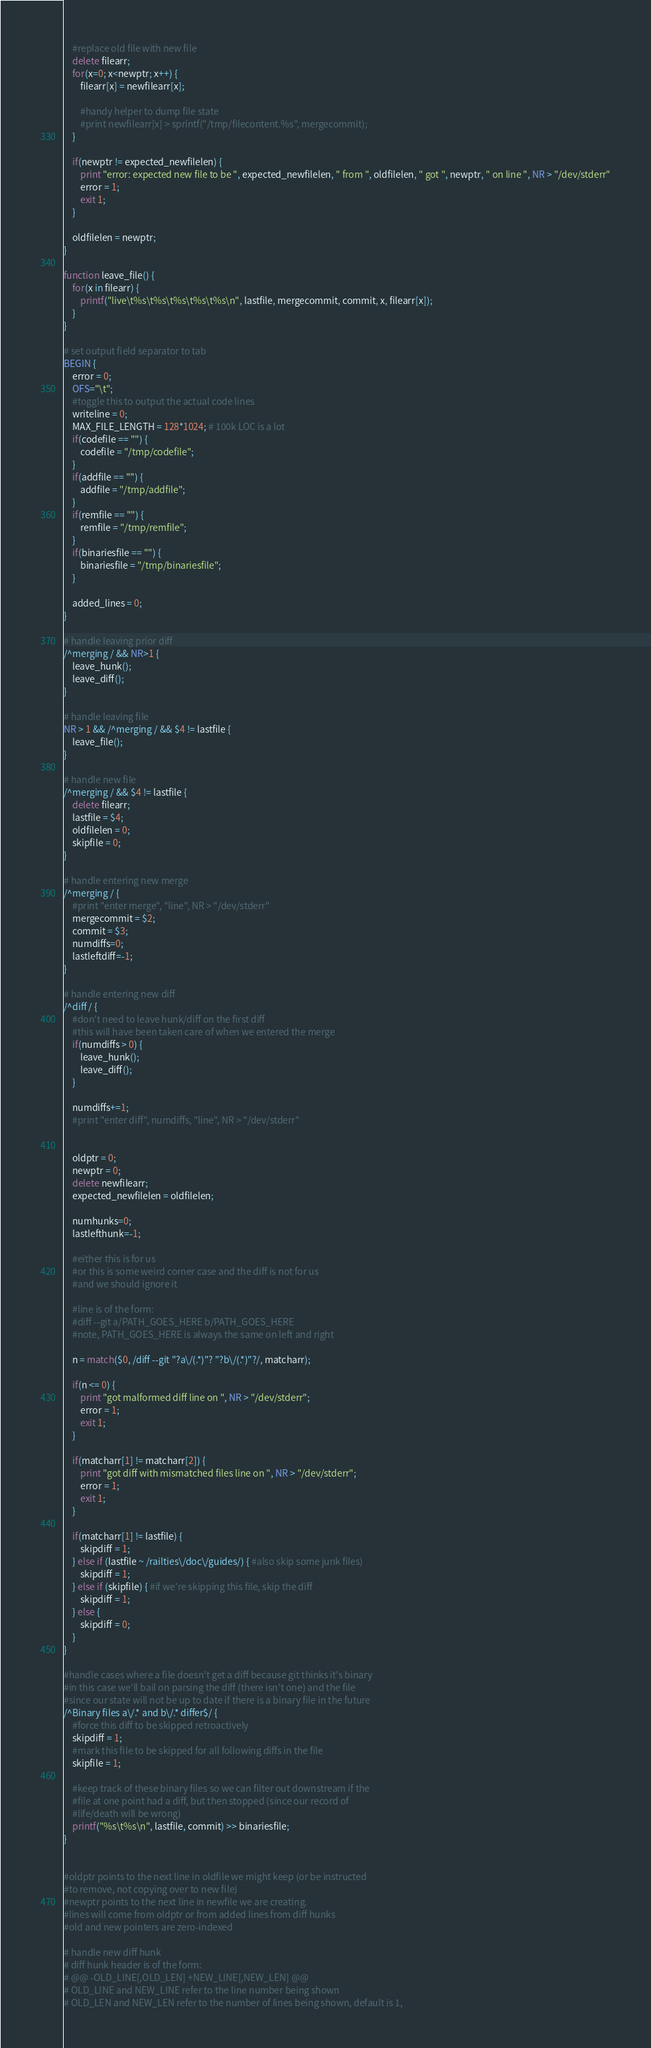Convert code to text. <code><loc_0><loc_0><loc_500><loc_500><_Awk_>
    #replace old file with new file
    delete filearr;
    for(x=0; x<newptr; x++) {
        filearr[x] = newfilearr[x];

        #handy helper to dump file state
        #print newfilearr[x] > sprintf("/tmp/filecontent.%s", mergecommit);
    }

    if(newptr != expected_newfilelen) {
        print "error: expected new file to be ", expected_newfilelen, " from ", oldfilelen, " got ", newptr, " on line ", NR > "/dev/stderr"
        error = 1;
        exit 1;
    }

    oldfilelen = newptr;
}

function leave_file() {
    for(x in filearr) {
        printf("live\t%s\t%s\t%s\t%s\t%s\n", lastfile, mergecommit, commit, x, filearr[x]);
    }
}

# set output field separator to tab
BEGIN {
    error = 0;
    OFS="\t";
    #toggle this to output the actual code lines
    writeline = 0;
    MAX_FILE_LENGTH = 128*1024; # 100k LOC is a lot
    if(codefile == "") {
        codefile = "/tmp/codefile";
    }
    if(addfile == "") {
        addfile = "/tmp/addfile";
    }
    if(remfile == "") {
        remfile = "/tmp/remfile";
    }
    if(binariesfile == "") {
        binariesfile = "/tmp/binariesfile";
    }

    added_lines = 0;
}

# handle leaving prior diff
/^merging / && NR>1 {
    leave_hunk();
    leave_diff();
}

# handle leaving file
NR > 1 && /^merging / && $4 != lastfile {
    leave_file();
}

# handle new file
/^merging / && $4 != lastfile {
    delete filearr;
    lastfile = $4;
    oldfilelen = 0;
    skipfile = 0;
}

# handle entering new merge
/^merging / {
    #print "enter merge", "line", NR > "/dev/stderr"
    mergecommit = $2;
    commit = $3;
    numdiffs=0;
    lastleftdiff=-1;
}

# handle entering new diff
/^diff / {
    #don't need to leave hunk/diff on the first diff
    #this will have been taken care of when we entered the merge
    if(numdiffs > 0) {
        leave_hunk();
        leave_diff();
    }

    numdiffs+=1;
    #print "enter diff", numdiffs, "line", NR > "/dev/stderr"


    oldptr = 0;
    newptr = 0;
    delete newfilearr;
    expected_newfilelen = oldfilelen;

    numhunks=0;
    lastlefthunk=-1;

    #either this is for us
    #or this is some weird corner case and the diff is not for us
    #and we should ignore it

    #line is of the form:
    #diff --git a/PATH_GOES_HERE b/PATH_GOES_HERE
    #note, PATH_GOES_HERE is always the same on left and right

    n = match($0, /diff --git "?a\/(.*)"? "?b\/(.*)"?/, matcharr);

    if(n <= 0) {
        print "got malformed diff line on ", NR > "/dev/stderr";
        error = 1;
        exit 1;
    }

    if(matcharr[1] != matcharr[2]) {
        print "got diff with mismatched files line on ", NR > "/dev/stderr";
        error = 1;
        exit 1;
    }

    if(matcharr[1] != lastfile) {
        skipdiff = 1;
    } else if (lastfile ~ /railties\/doc\/guides/) { #also skip some junk files)
        skipdiff = 1;
    } else if (skipfile) { #if we're skipping this file, skip the diff
        skipdiff = 1;
    } else {
        skipdiff = 0;
    }
}

#handle cases where a file doesn't get a diff because git thinks it's binary
#in this case we'll bail on parsing the diff (there isn't one) and the file
#since our state will not be up to date if there is a binary file in the future
/^Binary files a\/.* and b\/.* differ$/ {
    #force this diff to be skipped retroactively
    skipdiff = 1;
    #mark this file to be skipped for all following diffs in the file
    skipfile = 1;

    #keep track of these binary files so we can filter out downstream if the
    #file at one point had a diff, but then stopped (since our record of 
    #life/death will be wrong)
    printf("%s\t%s\n", lastfile, commit) >> binariesfile;
}


#oldptr points to the next line in oldfile we might keep (or be instructed
#to remove, not copying over to new file)
#newptr points to the next line in newfile we are creating.
#lines will come from oldptr or from added lines from diff hunks
#old and new pointers are zero-indexed

# handle new diff hunk
# diff hunk header is of the form:
# @@ -OLD_LINE[,OLD_LEN] +NEW_LINE[,NEW_LEN] @@
# OLD_LINE and NEW_LINE refer to the line number being shown
# OLD_LEN and NEW_LEN refer to the number of lines being shown, default is 1,</code> 